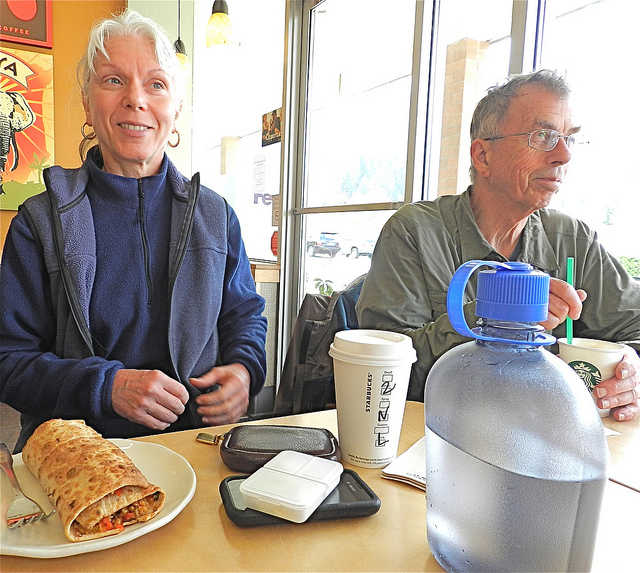Extract all visible text content from this image. COFFEE 